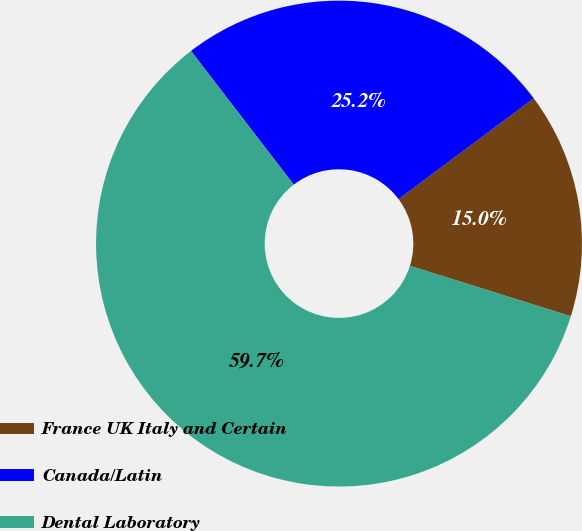Convert chart to OTSL. <chart><loc_0><loc_0><loc_500><loc_500><pie_chart><fcel>France UK Italy and Certain<fcel>Canada/Latin<fcel>Dental Laboratory<nl><fcel>15.04%<fcel>25.23%<fcel>59.74%<nl></chart> 